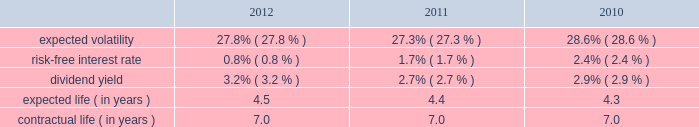Republic services , inc .
Notes to consolidated financial statements 2014 ( continued ) in december 2008 , the board of directors amended and restated the republic services , inc .
2006 incentive stock plan ( formerly known as the allied waste industries , inc .
2006 incentive stock plan ( the 2006 plan ) ) .
Allied 2019s stockholders approved the 2006 plan in may 2006 .
The 2006 plan was amended and restated in december 2008 to reflect that republic services , inc .
Is the new sponsor of the plan , that any references to shares of common stock is to shares of common stock of republic services , inc. , and to adjust outstanding awards and the number of shares available under the plan to reflect the acquisition .
The 2006 plan , as amended and restated , provides for the grant of non-qualified stock options , incentive stock options , shares of restricted stock , shares of phantom stock , stock bonuses , restricted stock units , stock appreciation rights , performance awards , dividend equivalents , cash awards , or other stock-based awards .
Awards granted under the 2006 plan prior to december 5 , 2008 became fully vested and nonforfeitable upon the closing of the acquisition .
Awards may be granted under the 2006 plan , as amended and restated , after december 5 , 2008 only to employees and consultants of allied waste industries , inc .
And its subsidiaries who were not employed by republic services , inc .
Prior to such date .
At december 31 , 2012 , there were approximately 15.5 million shares of common stock reserved for future grants under the 2006 plan .
Stock options we use a binomial option-pricing model to value our stock option grants .
We recognize compensation expense on a straight-line basis over the requisite service period for each separately vesting portion of the award , or to the employee 2019s retirement eligible date , if earlier .
Expected volatility is based on the weighted average of the most recent one year volatility and a historical rolling average volatility of our stock over the expected life of the option .
The risk-free interest rate is based on federal reserve rates in effect for bonds with maturity dates equal to the expected term of the option .
We use historical data to estimate future option exercises , forfeitures ( at 3.0% ( 3.0 % ) for each of the period presented ) and expected life of the options .
When appropriate , separate groups of employees that have similar historical exercise behavior are considered separately for valuation purposes .
The weighted-average estimated fair values of stock options granted during the years ended december 31 , 2012 , 2011 and 2010 were $ 4.77 , $ 5.35 and $ 5.28 per option , respectively , which were calculated using the following weighted-average assumptions: .

What was the percentage decline in the weighted-average estimated fair values of stock options granted from 2011 to 2012? 
Rationale: the change in the percent is the change from the early period to the most recent divide by the early period
Computations: (4.77 - 5.35)
Answer: -0.58. 